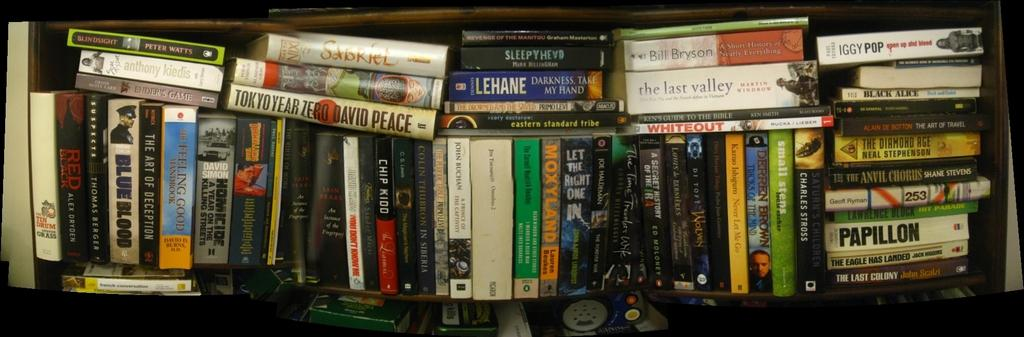<image>
Summarize the visual content of the image. the word Papillon is on the white book 